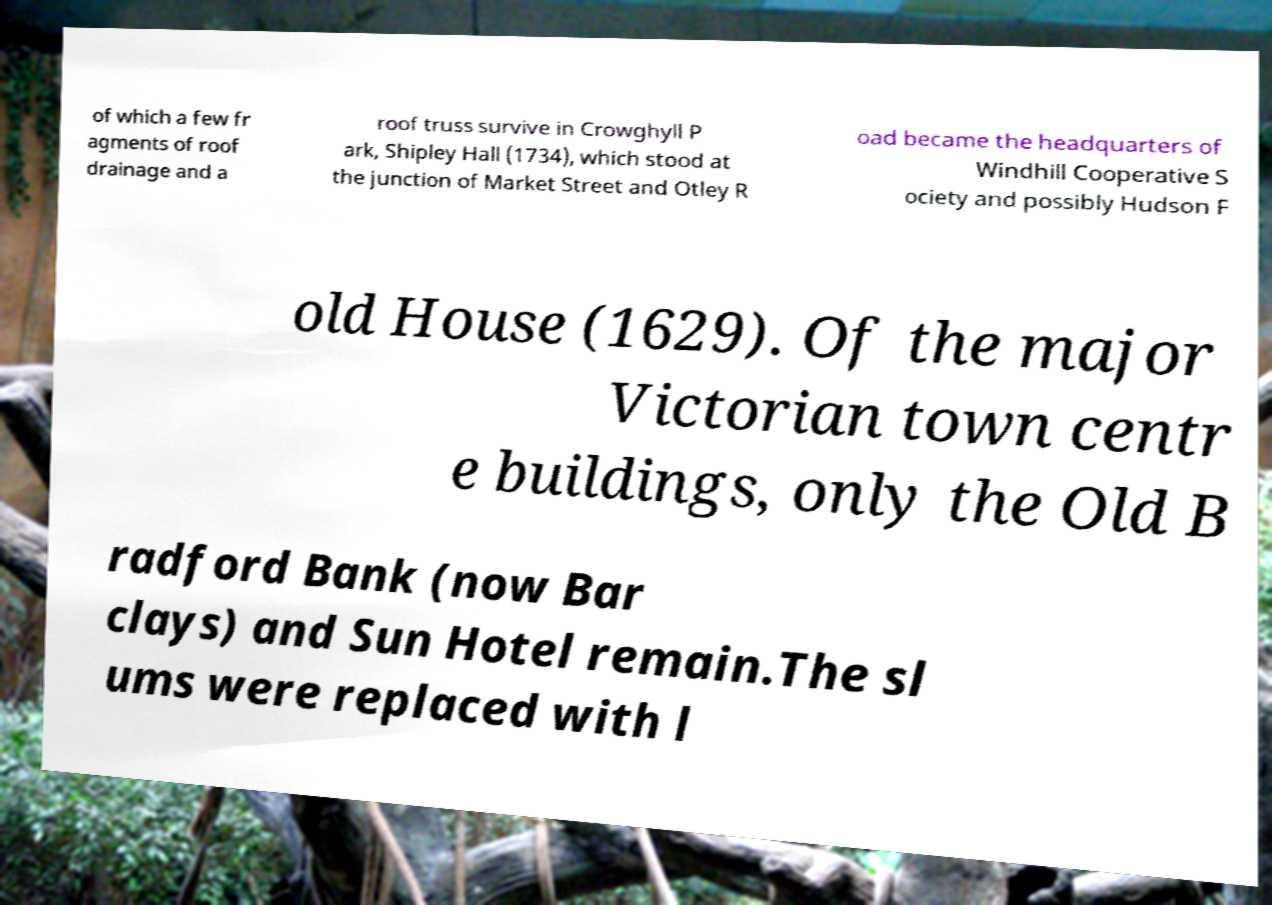Could you extract and type out the text from this image? of which a few fr agments of roof drainage and a roof truss survive in Crowghyll P ark, Shipley Hall (1734), which stood at the junction of Market Street and Otley R oad became the headquarters of Windhill Cooperative S ociety and possibly Hudson F old House (1629). Of the major Victorian town centr e buildings, only the Old B radford Bank (now Bar clays) and Sun Hotel remain.The sl ums were replaced with l 